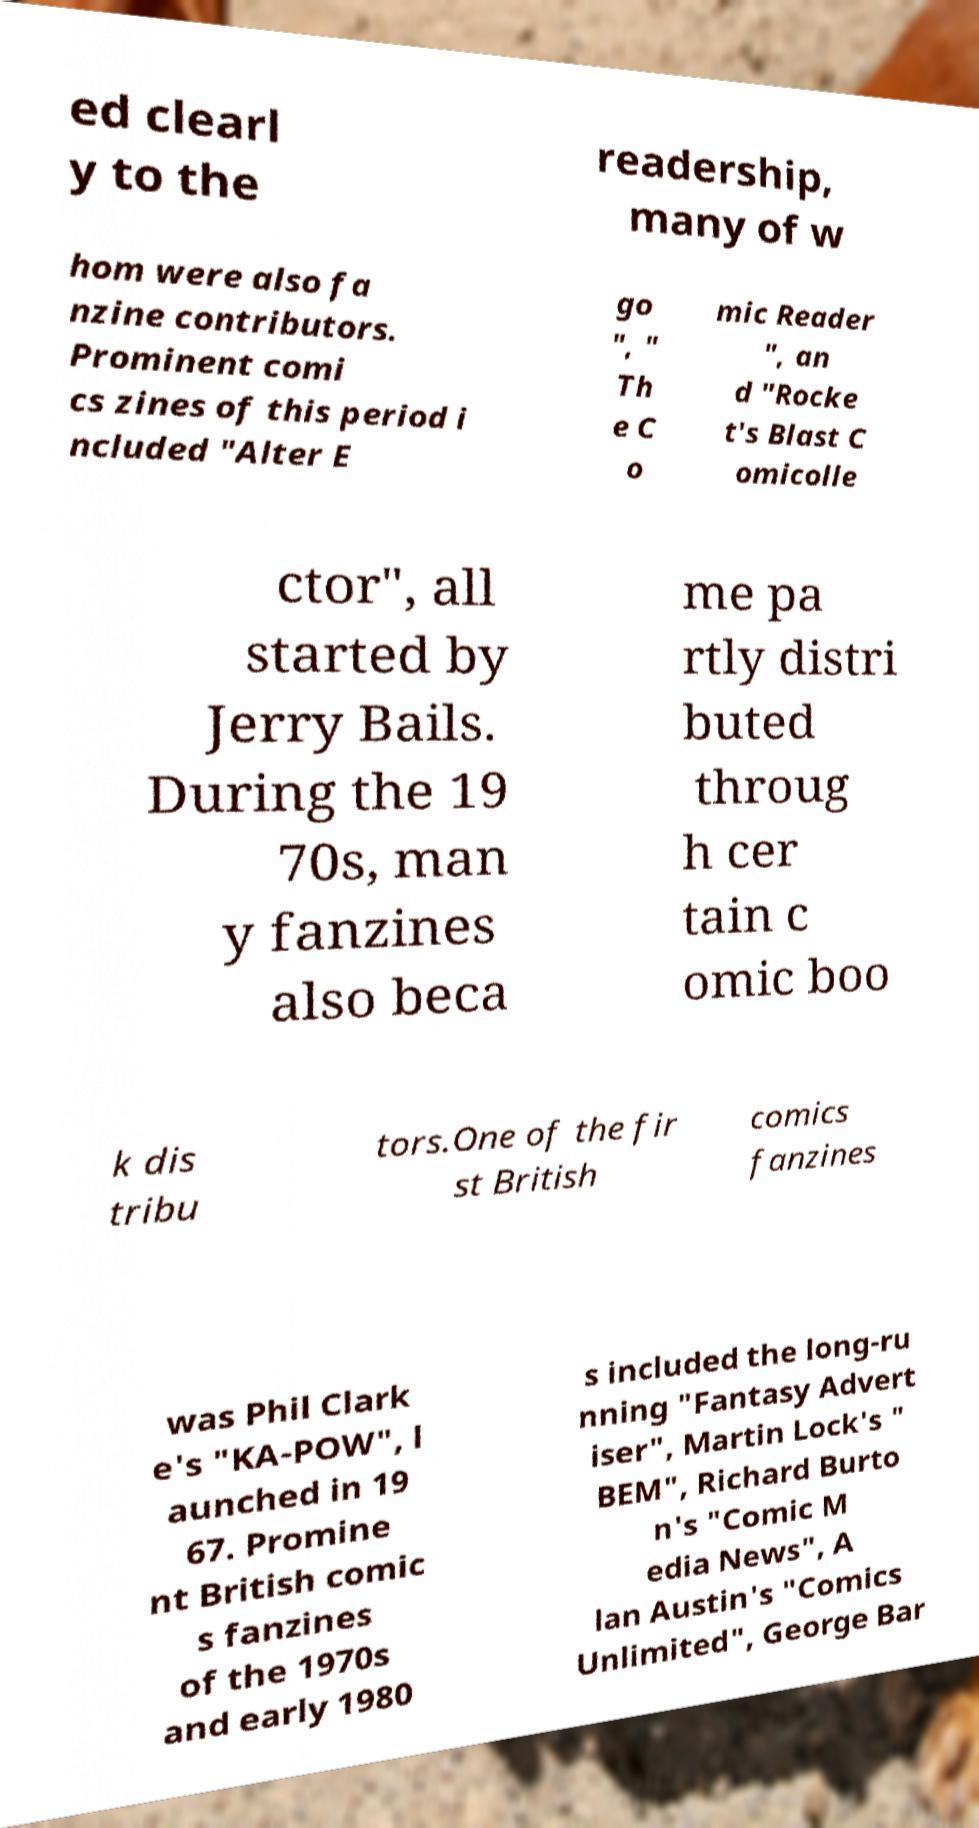Please identify and transcribe the text found in this image. ed clearl y to the readership, many of w hom were also fa nzine contributors. Prominent comi cs zines of this period i ncluded "Alter E go ", " Th e C o mic Reader ", an d "Rocke t's Blast C omicolle ctor", all started by Jerry Bails. During the 19 70s, man y fanzines also beca me pa rtly distri buted throug h cer tain c omic boo k dis tribu tors.One of the fir st British comics fanzines was Phil Clark e's "KA-POW", l aunched in 19 67. Promine nt British comic s fanzines of the 1970s and early 1980 s included the long-ru nning "Fantasy Advert iser", Martin Lock's " BEM", Richard Burto n's "Comic M edia News", A lan Austin's "Comics Unlimited", George Bar 